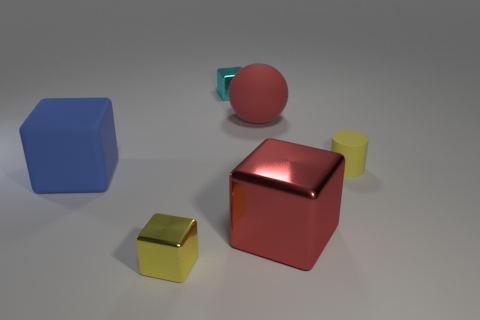Add 3 small cyan cylinders. How many objects exist? 9 Subtract all metallic cubes. How many cubes are left? 1 Subtract all blue blocks. How many blocks are left? 3 Subtract 3 cubes. How many cubes are left? 1 Add 4 shiny blocks. How many shiny blocks are left? 7 Add 5 yellow blocks. How many yellow blocks exist? 6 Subtract 0 brown blocks. How many objects are left? 6 Subtract all blocks. How many objects are left? 2 Subtract all purple blocks. Subtract all cyan balls. How many blocks are left? 4 Subtract all blue cylinders. How many blue blocks are left? 1 